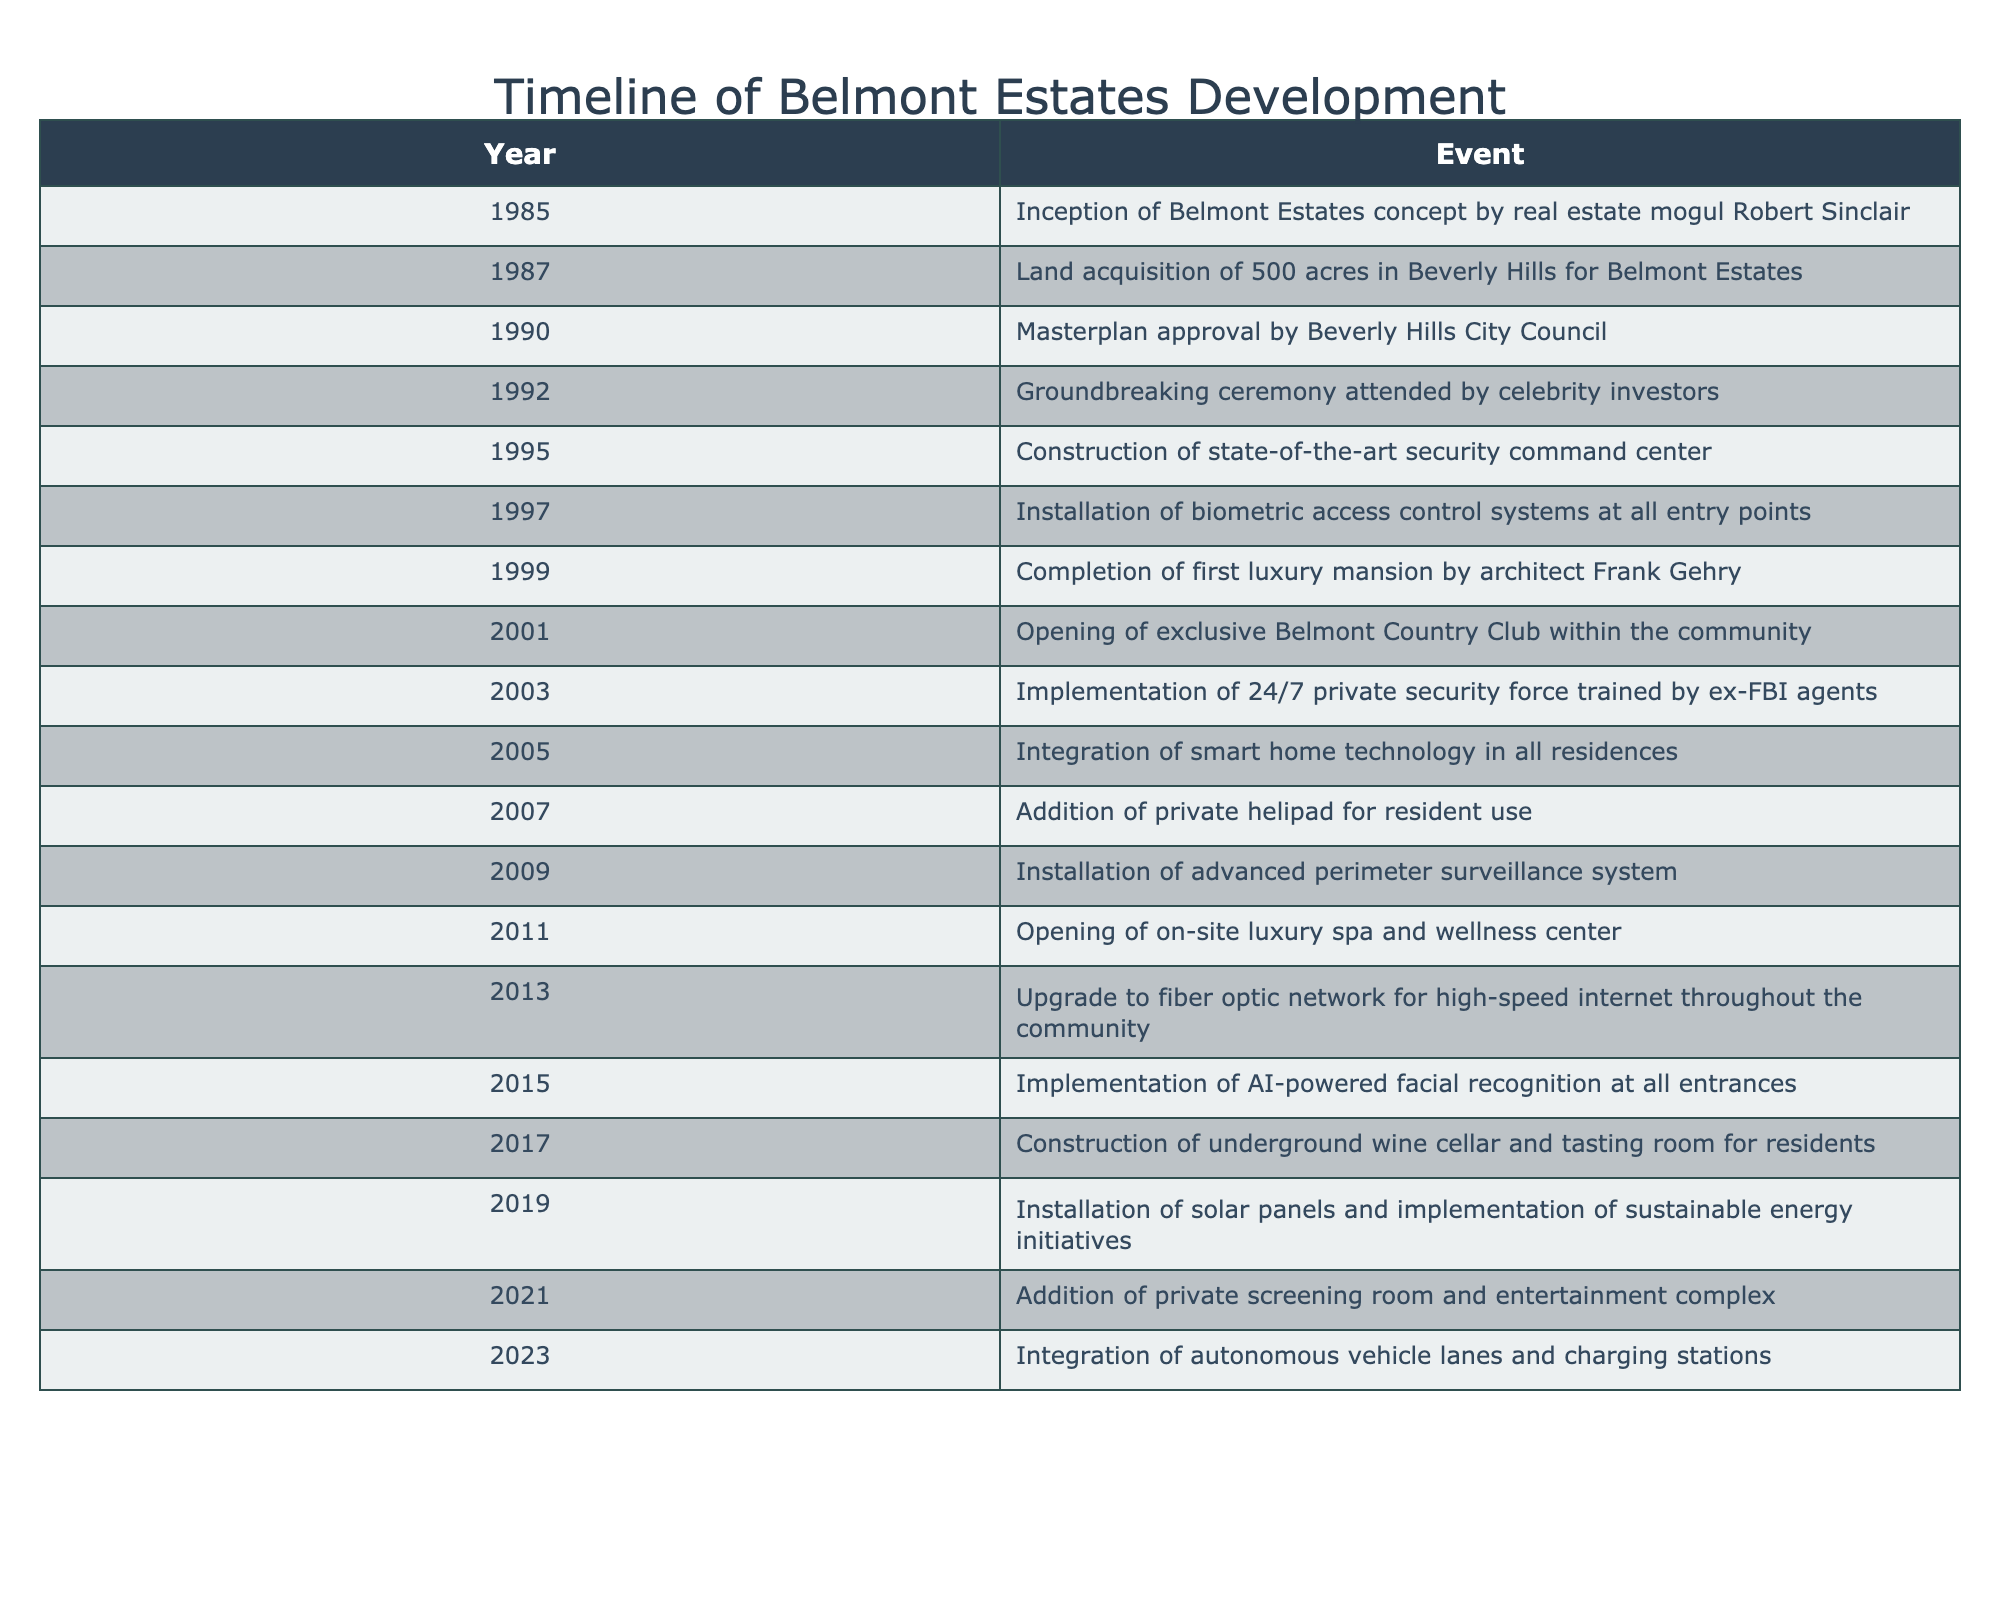What year did the groundbreaking ceremony take place? The table indicates that the groundbreaking ceremony occurred in 1992. This can be found by scanning the "Year" column for the event associated with the "Groundbreaking ceremony."
Answer: 1992 Which event happened last in the timeline? The last event listed in the timeline is the integration of autonomous vehicle lanes and charging stations, which took place in 2023. This is confirmed by looking at the final row of the table.
Answer: 2023 How many years apart were the installation of the biometric access control systems and the completion of the first luxury mansion? The installation of the biometric access control systems occurred in 1997, while the completion of the first luxury mansion was in 1999. The difference between these years is 1999 - 1997 = 2 years.
Answer: 2 years Did the community implement solar panels before the addition of the private helipad? The addition of the private helipad occurred in 2007, while the installation of solar panels took place in 2019. Since 2007 is before 2019, the answer is no; solar panels were not implemented before the helipad was added.
Answer: No What percentage of the events relate to security enhancements? There are 6 security-related events in the timeline (events in 1995, 1997, 2003, 2005, 2015, and 2019) out of a total of 20 events. To find the percentage, calculate (6/20) * 100 = 30%.
Answer: 30% What was the third event related to technology in the timeline? The third technology-related event is the installation of smart home technology in 2005. To identify this, examine all events categorized under technology advancements: 1995 (security command center), 2003 (private security force), and then 2005 for smart home technology.
Answer: 2005 Which year experienced the most events, and how many events occurred that year? The year with the most events is 2003, which has 2 events (the implementation of the private security force and the addition of the private helipad). Reviewing the timeline, 2003 stands out with these two sequential events.
Answer: 2 events in 2003 Was the exclusive Belmont Country Club opened before or after the installation of advanced perimeter surveillance? The exclusive Belmont Country Club opened in 2001, while the advanced perimeter surveillance system was installed in 2009. Therefore, the club opened before the surveillance was installed, as verified by comparing the years in the timeline.
Answer: Before How many events occurred in the 2010s decade? Five events occurred in the 2010s decade: 2011 (luxury spa), 2013 (fiber optic network), 2015 (AI facial recognition), 2017 (wine cellar), and 2019 (solar panels). Counting these specific years reveals a total of 5 events during this decade.
Answer: 5 events 